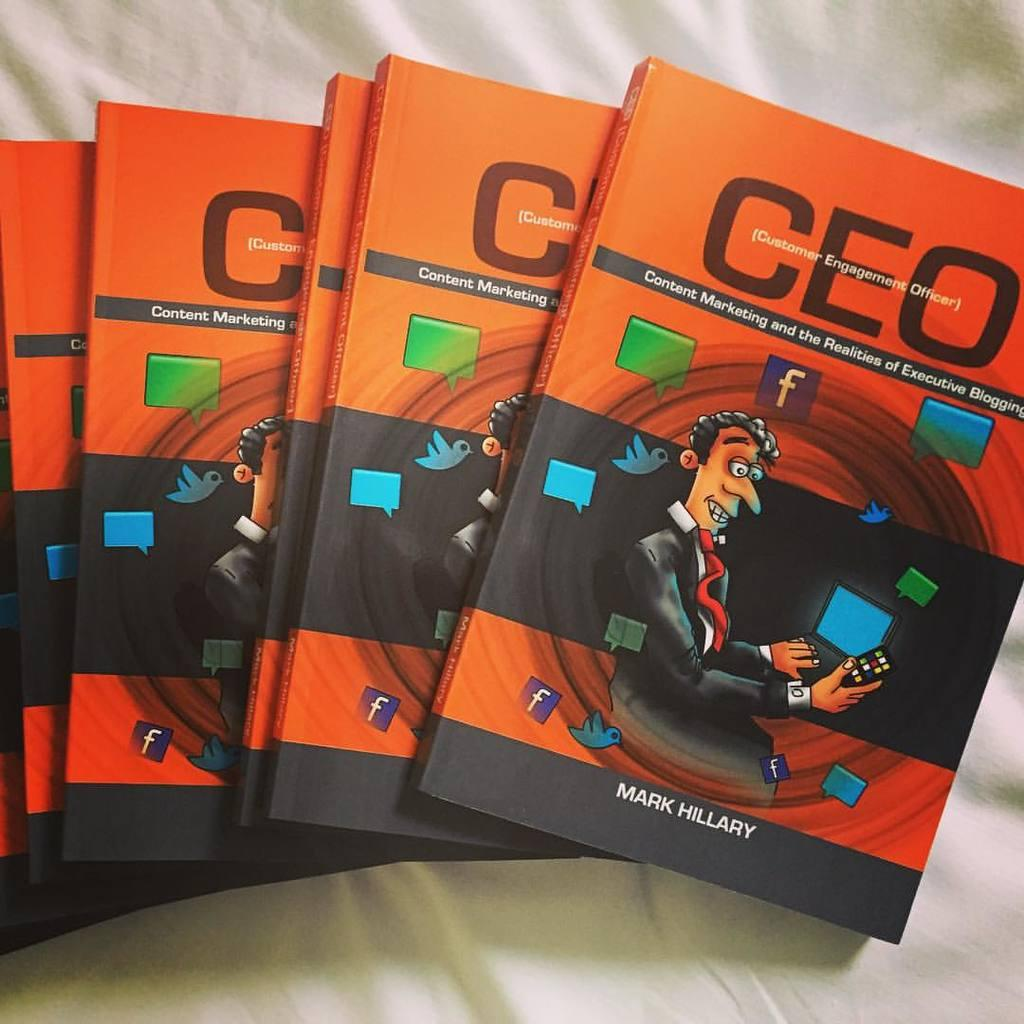<image>
Share a concise interpretation of the image provided. Five copies of the book "CEO" by Mark Hillary are displayed on a white background. 